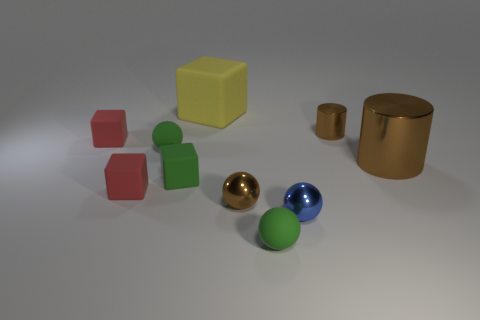Is there another big matte object that has the same shape as the yellow rubber object?
Keep it short and to the point. No. There is a tiny brown object left of the rubber thing that is on the right side of the yellow thing; what shape is it?
Your response must be concise. Sphere. There is a small rubber ball that is to the left of the yellow rubber cube; what is its color?
Offer a very short reply. Green. There is another green cube that is the same material as the big block; what size is it?
Your answer should be compact. Small. The brown metal thing that is the same shape as the tiny blue metal thing is what size?
Give a very brief answer. Small. Is there a large red shiny sphere?
Your response must be concise. No. How many objects are balls that are behind the blue shiny sphere or tiny shiny objects?
Ensure brevity in your answer.  4. There is a blue sphere that is the same size as the green block; what material is it?
Ensure brevity in your answer.  Metal. The cylinder that is behind the cylinder that is to the right of the tiny cylinder is what color?
Your response must be concise. Brown. How many brown shiny things are in front of the tiny green matte cube?
Your answer should be very brief. 1. 